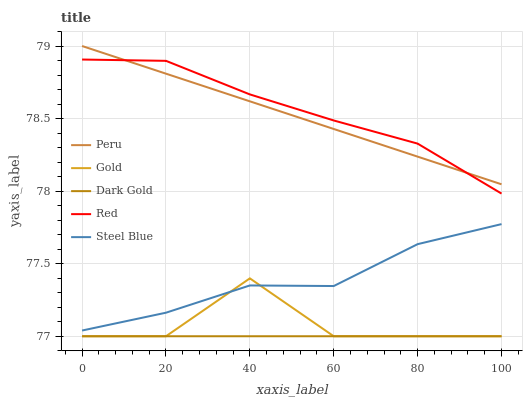Does Steel Blue have the minimum area under the curve?
Answer yes or no. No. Does Steel Blue have the maximum area under the curve?
Answer yes or no. No. Is Steel Blue the smoothest?
Answer yes or no. No. Is Steel Blue the roughest?
Answer yes or no. No. Does Steel Blue have the lowest value?
Answer yes or no. No. Does Steel Blue have the highest value?
Answer yes or no. No. Is Dark Gold less than Red?
Answer yes or no. Yes. Is Red greater than Steel Blue?
Answer yes or no. Yes. Does Dark Gold intersect Red?
Answer yes or no. No. 